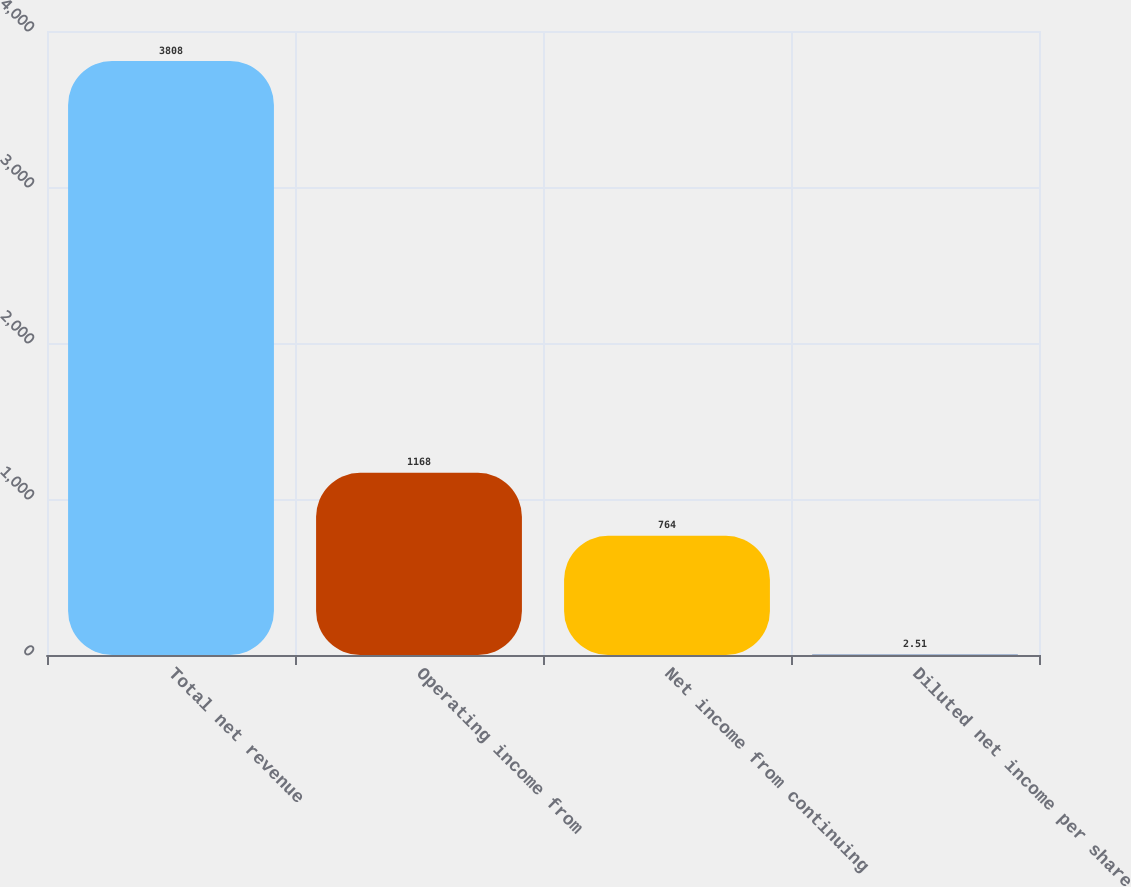<chart> <loc_0><loc_0><loc_500><loc_500><bar_chart><fcel>Total net revenue<fcel>Operating income from<fcel>Net income from continuing<fcel>Diluted net income per share<nl><fcel>3808<fcel>1168<fcel>764<fcel>2.51<nl></chart> 